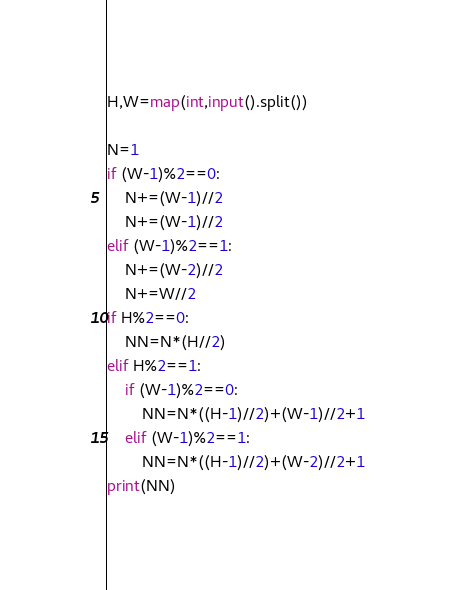Convert code to text. <code><loc_0><loc_0><loc_500><loc_500><_Python_>H,W=map(int,input().split())

N=1
if (W-1)%2==0:
    N+=(W-1)//2
    N+=(W-1)//2
elif (W-1)%2==1:
    N+=(W-2)//2
    N+=W//2
if H%2==0:
    NN=N*(H//2)
elif H%2==1:
    if (W-1)%2==0:
        NN=N*((H-1)//2)+(W-1)//2+1
    elif (W-1)%2==1:
        NN=N*((H-1)//2)+(W-2)//2+1
print(NN)</code> 